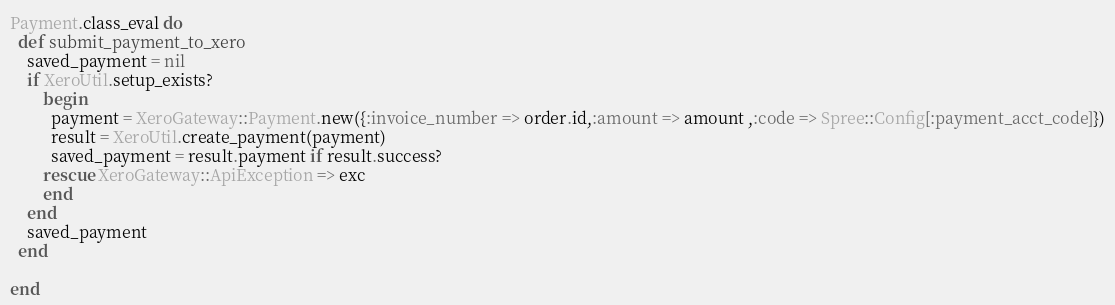<code> <loc_0><loc_0><loc_500><loc_500><_Ruby_>Payment.class_eval do
  def submit_payment_to_xero
    saved_payment = nil
    if XeroUtil.setup_exists?
        begin
          payment = XeroGateway::Payment.new({:invoice_number => order.id,:amount => amount ,:code => Spree::Config[:payment_acct_code]})
          result = XeroUtil.create_payment(payment)
          saved_payment = result.payment if result.success?
        rescue XeroGateway::ApiException => exc
        end
    end
    saved_payment
  end

end</code> 